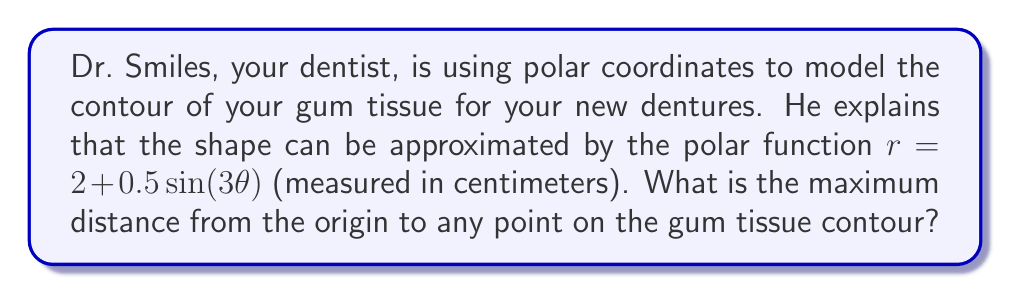What is the answer to this math problem? To find the maximum distance from the origin to any point on the gum tissue contour, we need to determine the maximum value of $r$ in the given polar function.

1) The polar function is given by:
   $r = 2 + 0.5\sin(3\theta)$

2) The sine function oscillates between -1 and 1. Therefore, $0.5\sin(3\theta)$ will oscillate between -0.5 and 0.5.

3) The maximum value of $r$ will occur when $0.5\sin(3\theta)$ is at its maximum, which is 0.5.

4) So, the maximum value of $r$ is:
   $r_{max} = 2 + 0.5 = 2.5$

5) This maximum occurs whenever $\sin(3\theta) = 1$, which happens when $3\theta = \frac{\pi}{2}, \frac{5\pi}{2}, \frac{9\pi}{2}$, etc., or when $\theta = \frac{\pi}{6}, \frac{5\pi}{6}, \frac{3\pi}{2}$, etc.

Therefore, the maximum distance from the origin to any point on the gum tissue contour is 2.5 centimeters.
Answer: The maximum distance from the origin to any point on the gum tissue contour is 2.5 centimeters. 